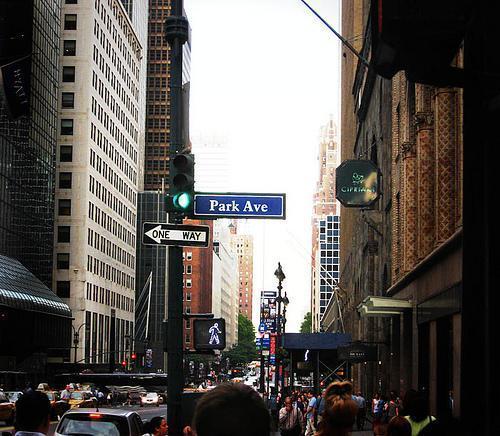How many people are wearing a Red Hat?
Give a very brief answer. 0. How many people are in the photo?
Give a very brief answer. 2. 